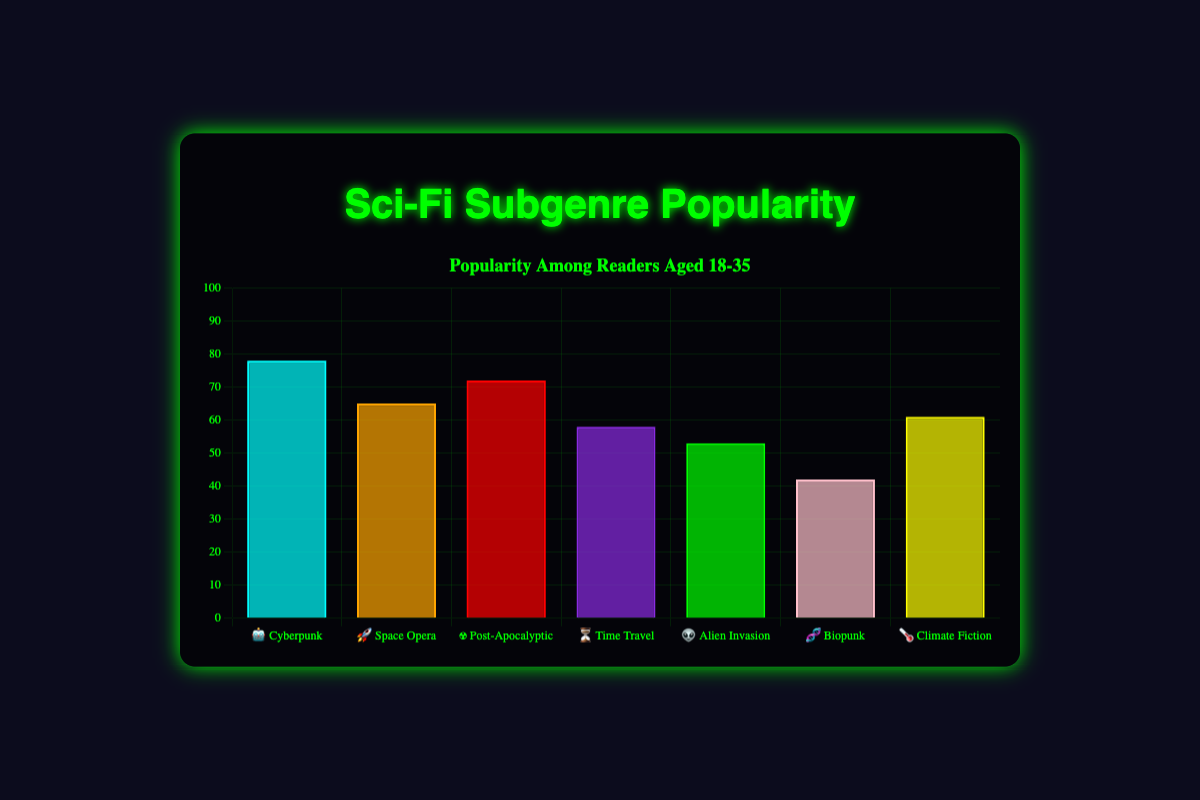which sci-fi subgenre has the highest popularity among readers aged 18-35? Look at the heights of the bars representing each subgenre; the tallest bar indicates the highest popularity. The "🤖 Cyberpunk" bar is the tallest with a value of 78.
Answer: Cyberpunk what is the popularity value for "☢️ Post-Apocalyptic"? Find the bar labeled with "☢️ Post-Apocalyptic" and look at its height. The popularity value shown is 72.
Answer: 72 how much more popular is "🤖 Cyberpunk" than "🧬 Biopunk"? Subtract the popularity value of "🧬 Biopunk" from "🤖 Cyberpunk": 78 - 42 = 36.
Answer: 36 which subgenre is the least popular and what is its popularity value? Identify the shortest bar to find the least popular subgenre; "🧬 Biopunk" has the shortest bar with a value of 42.
Answer: Biopunk; 42 arrange the subgenres in order of their popularity from highest to lowest. List the subgenres by decreasing height of their bars: Cyberpunk (78), Post-Apocalyptic (72), Space Opera (65), Climate Fiction (61), Time Travel (58), Alien Invasion (53), Biopunk (42).
Answer: Cyberpunk, Post-Apocalyptic, Space Opera, Climate Fiction, Time Travel, Alien Invasion, Biopunk what is the average popularity value of all the subgenres? Sum the popularity values and divide by the number of subgenres: (78 + 65 + 72 + 58 + 53 + 42 + 61) / 7 = 61.29.
Answer: 61.29 how does the difference in popularity between "🚀 Space Opera" and "👽 Alien Invasion" compare to the difference between "⏳ Time Travel" and "🤖 Cyberpunk"? Calculate the differences: Space Opera - Alien Invasion = 65 - 53 = 12; Time Travel - Cyberpunk = 58 - 78 = -20. "Space Opera vs Alien Invasion" has a smaller difference.
Answer: Space Opera vs Alien Invasion which subgenres have a popularity value above 60? Identify bars with a height representing a value above 60: Cyberpunk (78), Post-Apocalyptic (72), Space Opera (65), Climate Fiction (61).
Answer: Cyberpunk, Post-Apocalyptic, Space Opera, Climate Fiction what is the combined popularity of "🚀 Space Opera" and "🌡️ Climate Fiction"? Add the popularity values of both subgenres: 65 + 61 = 126.
Answer: 126 